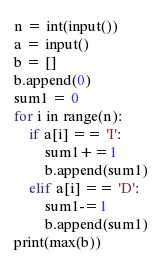Convert code to text. <code><loc_0><loc_0><loc_500><loc_500><_Python_>n = int(input())
a = input()
b = []
b.append(0)
sum1 = 0
for i in range(n):
    if a[i] == 'I':
        sum1+=1
        b.append(sum1)
    elif a[i] == 'D':
        sum1-=1
        b.append(sum1)
print(max(b))</code> 